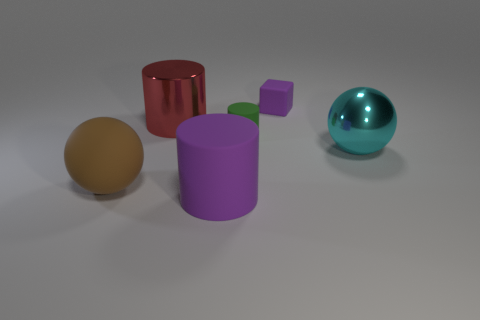Does the purple cube have the same size as the metal thing to the right of the red shiny object?
Give a very brief answer. No. There is a tiny thing that is behind the red metallic cylinder; what is its material?
Your answer should be compact. Rubber. How many things are behind the shiny ball and on the right side of the tiny cylinder?
Your answer should be compact. 1. What is the material of the purple block that is the same size as the green cylinder?
Give a very brief answer. Rubber. Is the size of the shiny object in front of the green rubber object the same as the purple rubber object that is behind the brown ball?
Ensure brevity in your answer.  No. There is a brown matte thing; are there any matte objects in front of it?
Your response must be concise. Yes. What color is the large cylinder in front of the metallic thing that is to the right of the small cube?
Ensure brevity in your answer.  Purple. Are there fewer large cyan rubber objects than large brown matte objects?
Keep it short and to the point. Yes. How many other brown objects have the same shape as the brown rubber object?
Offer a terse response. 0. There is another shiny ball that is the same size as the brown sphere; what is its color?
Your response must be concise. Cyan. 